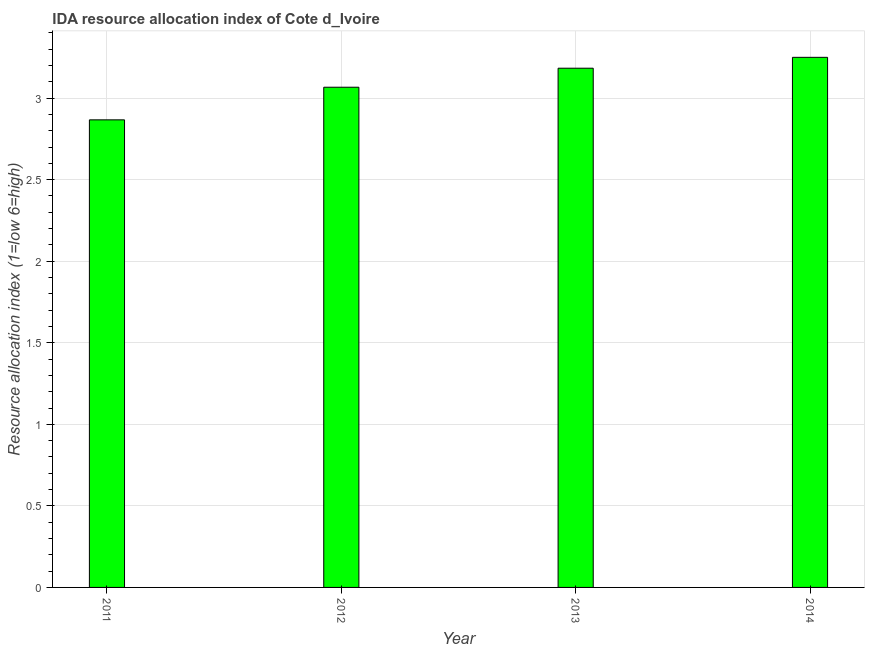What is the title of the graph?
Make the answer very short. IDA resource allocation index of Cote d_Ivoire. What is the label or title of the Y-axis?
Your answer should be compact. Resource allocation index (1=low 6=high). What is the ida resource allocation index in 2012?
Keep it short and to the point. 3.07. Across all years, what is the minimum ida resource allocation index?
Provide a succinct answer. 2.87. In which year was the ida resource allocation index minimum?
Give a very brief answer. 2011. What is the sum of the ida resource allocation index?
Offer a terse response. 12.37. What is the difference between the ida resource allocation index in 2011 and 2014?
Give a very brief answer. -0.38. What is the average ida resource allocation index per year?
Provide a short and direct response. 3.09. What is the median ida resource allocation index?
Give a very brief answer. 3.12. In how many years, is the ida resource allocation index greater than 3 ?
Ensure brevity in your answer.  3. Do a majority of the years between 2014 and 2011 (inclusive) have ida resource allocation index greater than 0.6 ?
Make the answer very short. Yes. Is the ida resource allocation index in 2011 less than that in 2012?
Keep it short and to the point. Yes. Is the difference between the ida resource allocation index in 2011 and 2012 greater than the difference between any two years?
Offer a very short reply. No. What is the difference between the highest and the second highest ida resource allocation index?
Provide a short and direct response. 0.07. What is the difference between the highest and the lowest ida resource allocation index?
Offer a terse response. 0.38. In how many years, is the ida resource allocation index greater than the average ida resource allocation index taken over all years?
Provide a succinct answer. 2. How many years are there in the graph?
Make the answer very short. 4. Are the values on the major ticks of Y-axis written in scientific E-notation?
Provide a succinct answer. No. What is the Resource allocation index (1=low 6=high) in 2011?
Keep it short and to the point. 2.87. What is the Resource allocation index (1=low 6=high) of 2012?
Your answer should be very brief. 3.07. What is the Resource allocation index (1=low 6=high) in 2013?
Provide a succinct answer. 3.18. What is the difference between the Resource allocation index (1=low 6=high) in 2011 and 2012?
Your answer should be compact. -0.2. What is the difference between the Resource allocation index (1=low 6=high) in 2011 and 2013?
Offer a very short reply. -0.32. What is the difference between the Resource allocation index (1=low 6=high) in 2011 and 2014?
Keep it short and to the point. -0.38. What is the difference between the Resource allocation index (1=low 6=high) in 2012 and 2013?
Provide a succinct answer. -0.12. What is the difference between the Resource allocation index (1=low 6=high) in 2012 and 2014?
Ensure brevity in your answer.  -0.18. What is the difference between the Resource allocation index (1=low 6=high) in 2013 and 2014?
Your answer should be compact. -0.07. What is the ratio of the Resource allocation index (1=low 6=high) in 2011 to that in 2012?
Your answer should be compact. 0.94. What is the ratio of the Resource allocation index (1=low 6=high) in 2011 to that in 2013?
Your answer should be very brief. 0.9. What is the ratio of the Resource allocation index (1=low 6=high) in 2011 to that in 2014?
Your answer should be very brief. 0.88. What is the ratio of the Resource allocation index (1=low 6=high) in 2012 to that in 2013?
Offer a very short reply. 0.96. What is the ratio of the Resource allocation index (1=low 6=high) in 2012 to that in 2014?
Provide a succinct answer. 0.94. 